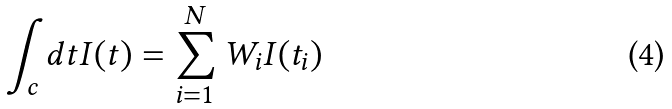<formula> <loc_0><loc_0><loc_500><loc_500>\int _ { c } d t I ( t ) = \sum _ { i = 1 } ^ { N } W _ { i } I ( t _ { i } )</formula> 